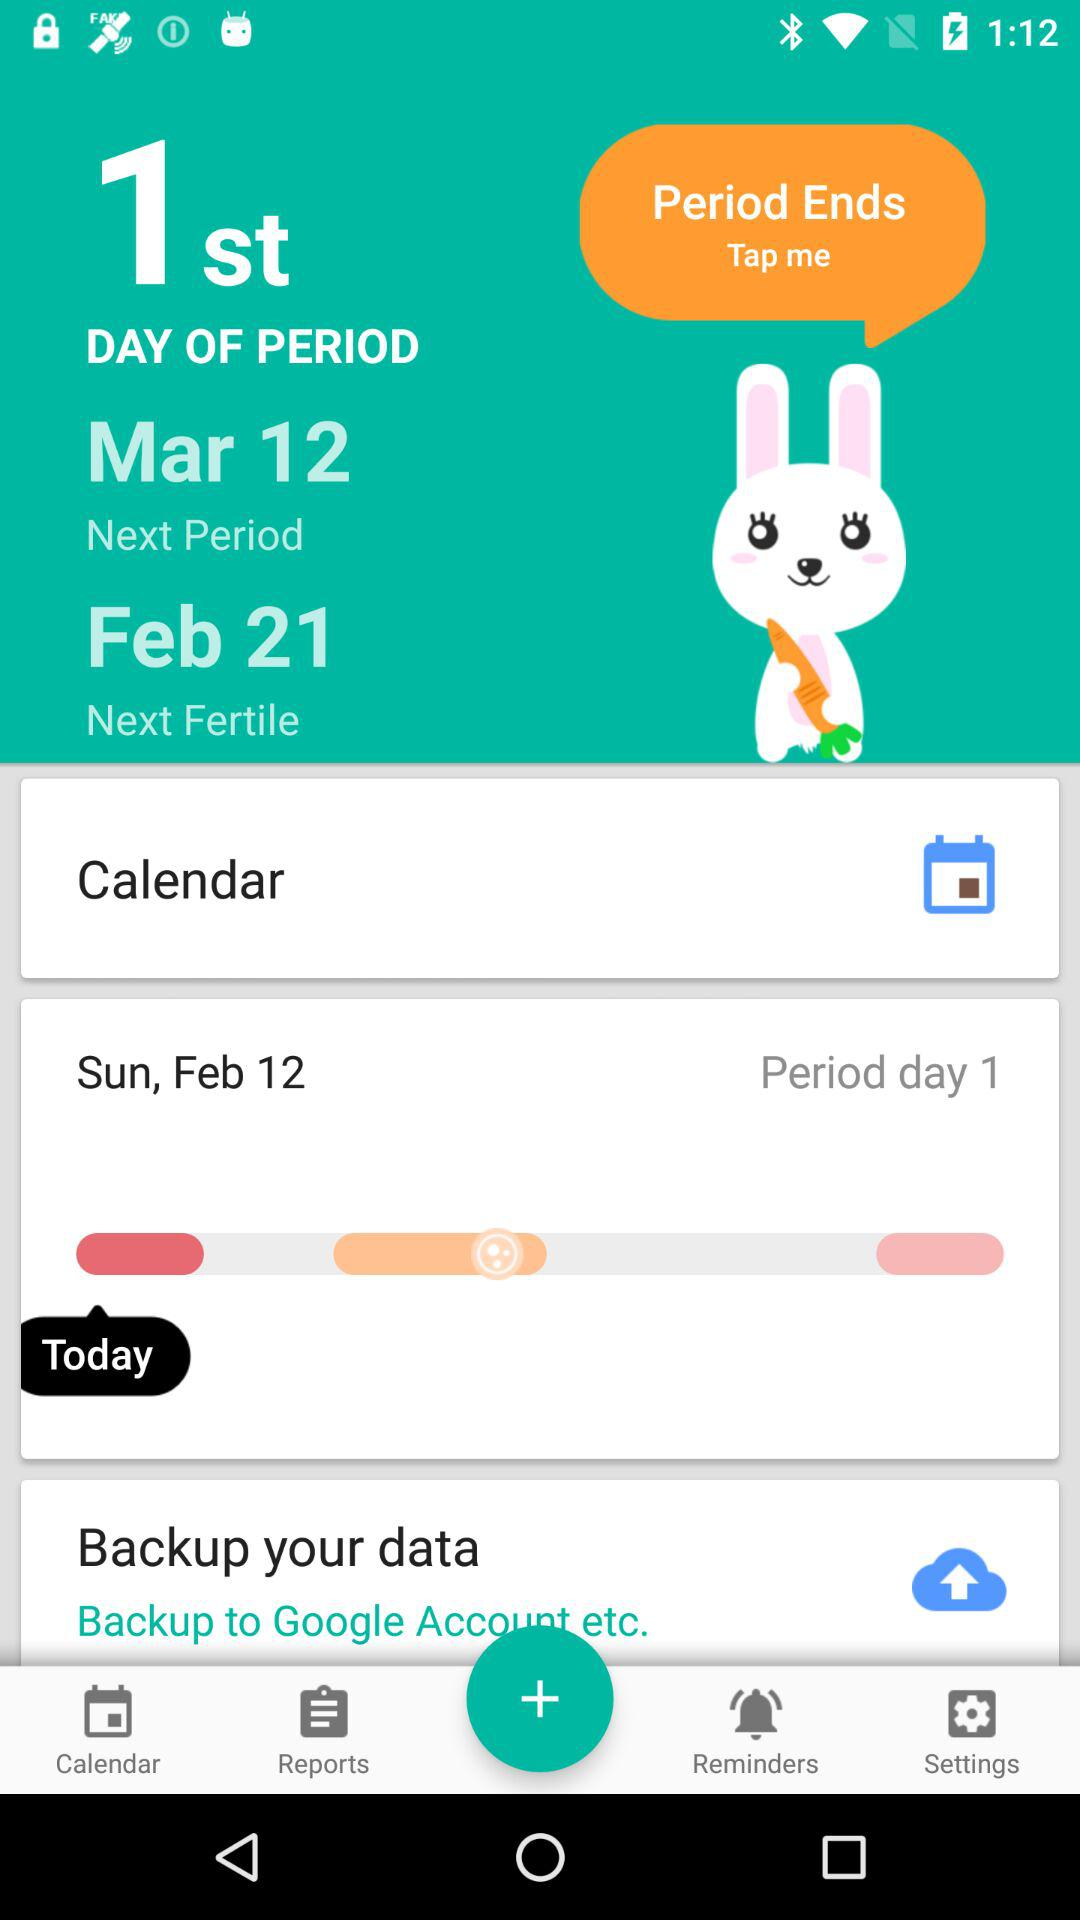What is the date of the next period? The date of the next period is March 12. 